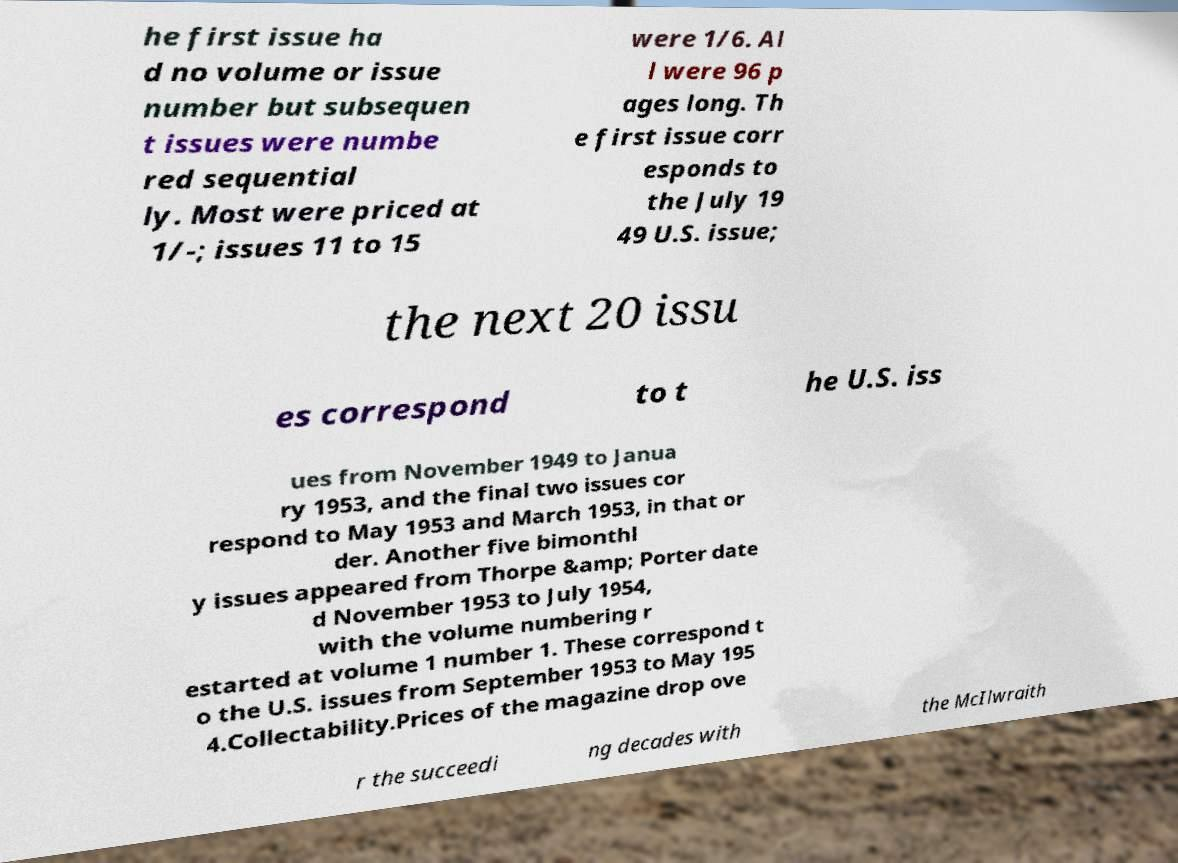There's text embedded in this image that I need extracted. Can you transcribe it verbatim? he first issue ha d no volume or issue number but subsequen t issues were numbe red sequential ly. Most were priced at 1/-; issues 11 to 15 were 1/6. Al l were 96 p ages long. Th e first issue corr esponds to the July 19 49 U.S. issue; the next 20 issu es correspond to t he U.S. iss ues from November 1949 to Janua ry 1953, and the final two issues cor respond to May 1953 and March 1953, in that or der. Another five bimonthl y issues appeared from Thorpe &amp; Porter date d November 1953 to July 1954, with the volume numbering r estarted at volume 1 number 1. These correspond t o the U.S. issues from September 1953 to May 195 4.Collectability.Prices of the magazine drop ove r the succeedi ng decades with the McIlwraith 